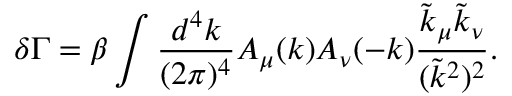Convert formula to latex. <formula><loc_0><loc_0><loc_500><loc_500>\delta \Gamma = \beta \int \frac { d ^ { 4 } k } { ( 2 \pi ) ^ { 4 } } A _ { \mu } ( k ) A _ { \nu } ( - k ) \frac { \tilde { k } _ { \mu } \tilde { k } _ { \nu } } { ( \tilde { k } ^ { 2 } ) ^ { 2 } } .</formula> 